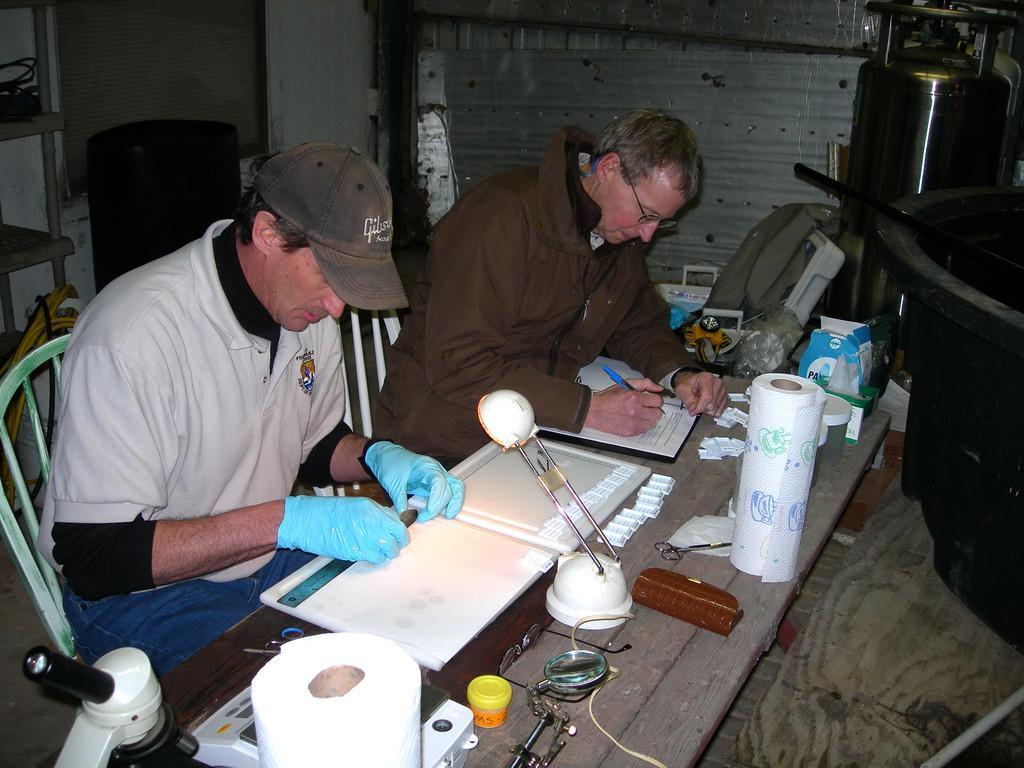Could you give a brief overview of what you see in this image? In this image there are papers,table lamp, roll, box and some items on the table, and in the background there are two persons sitting on the chairs and doing something, objects , rack. 